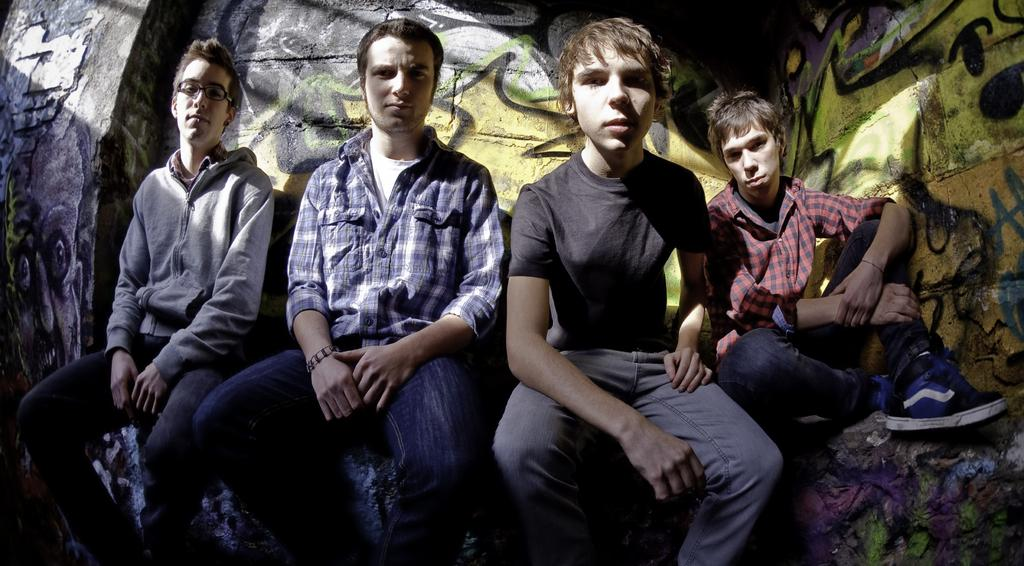How many people are in the image? There are four men in the image. What are the men doing in the image? The men are sitting on a rock. Can you describe the rock in the background of the image? There is a rock in the background of the image, and it has a painting on it. What type of bead is used to create the painting on the rock in the image? There is no mention of beads being used in the painting on the rock in the image. 